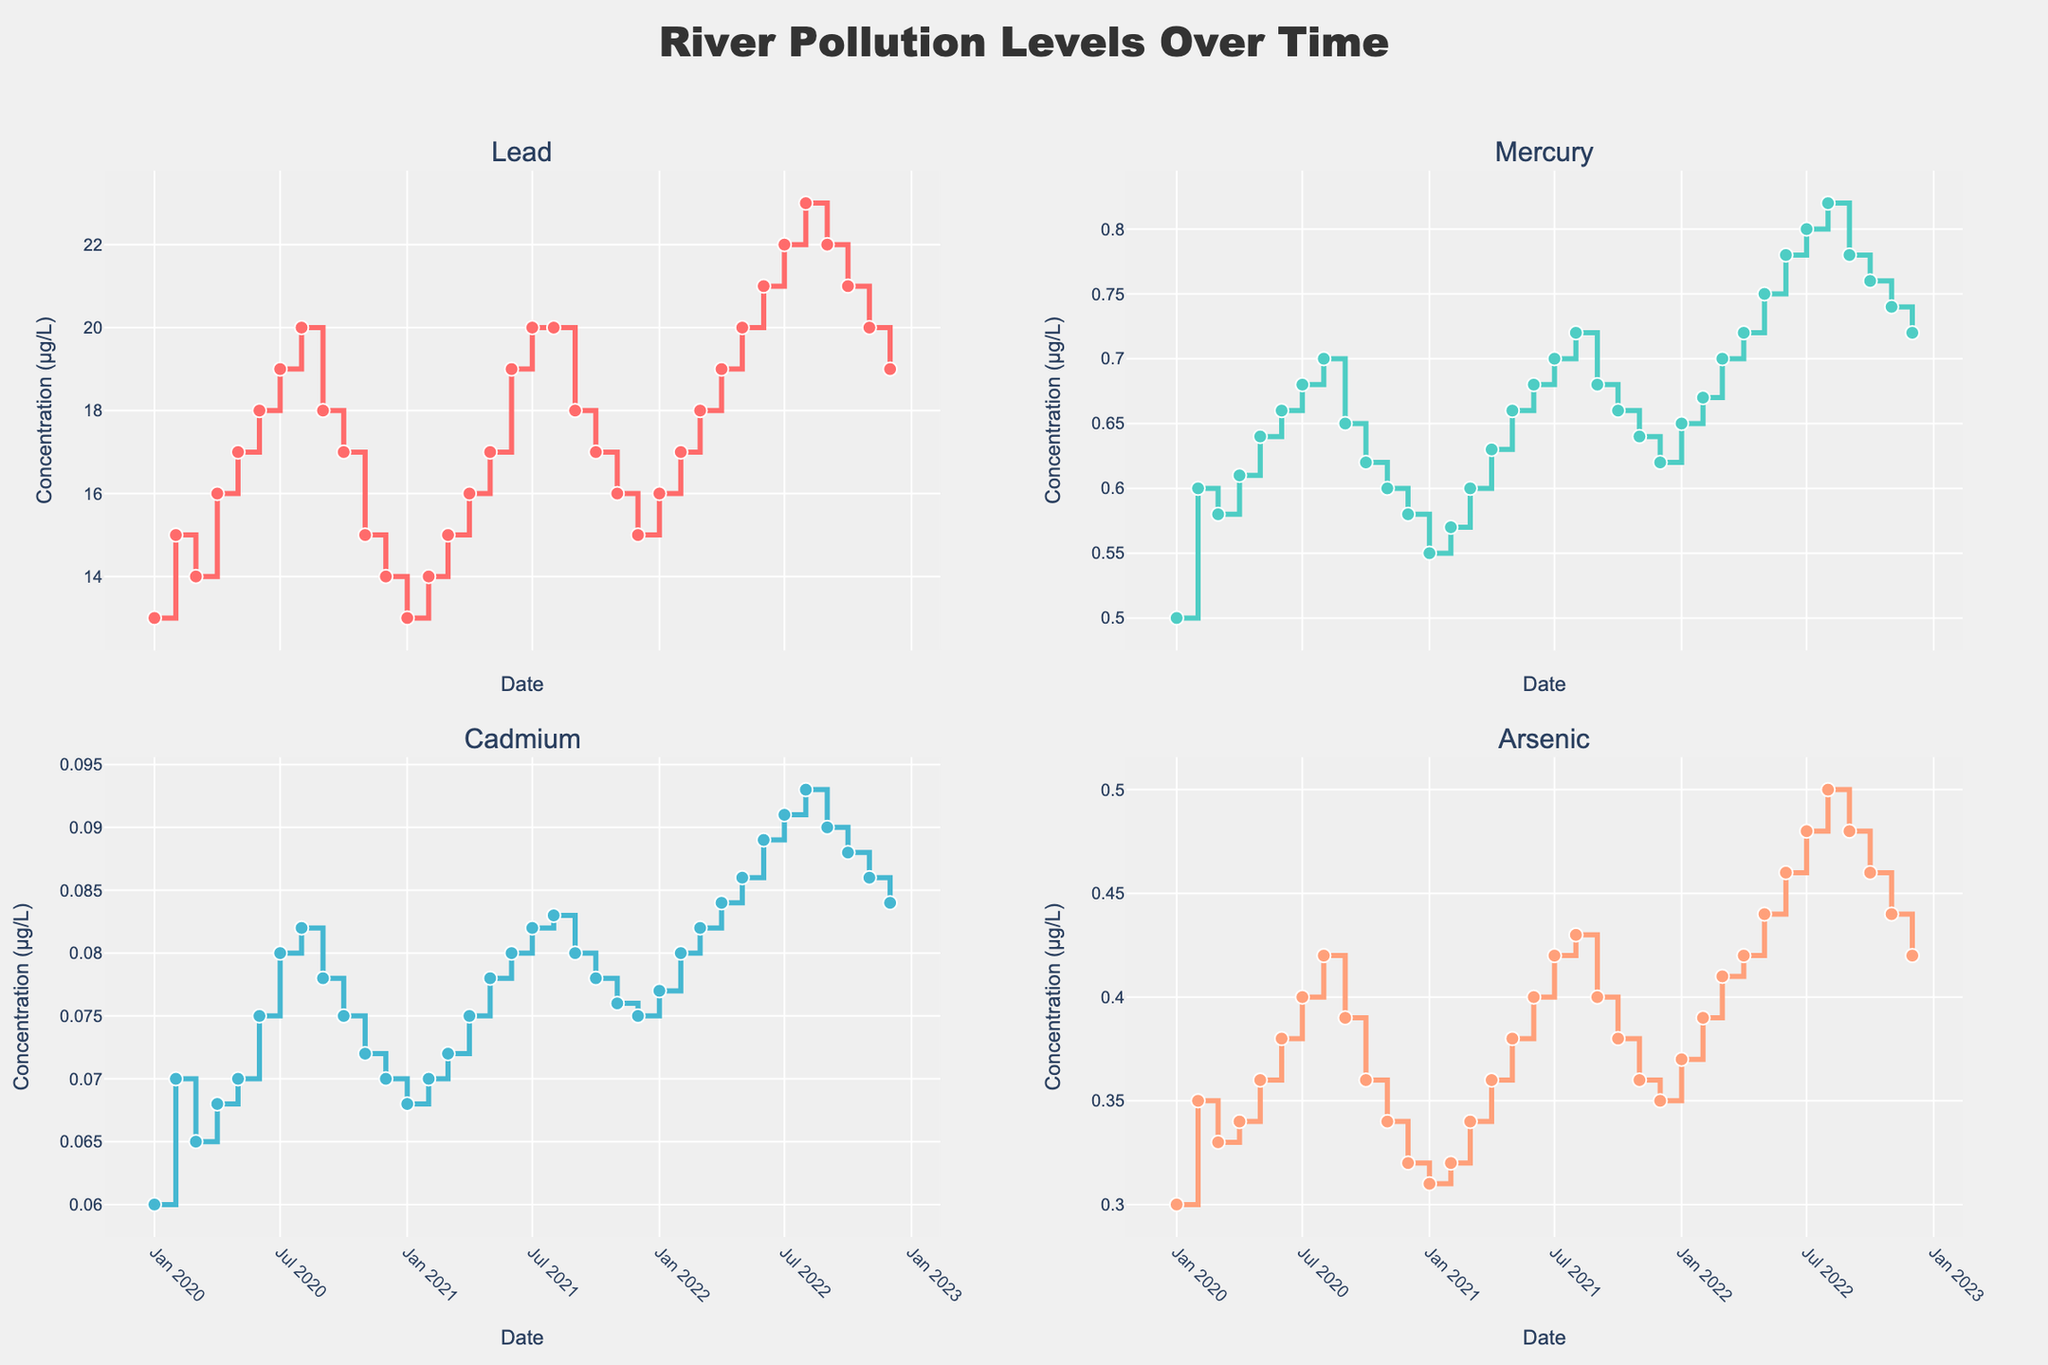What does the title of the figure indicate? The title "River Pollution Levels Over Time" indicates that the figure shows how pollution levels have changed over time in the river.
Answer: It shows pollution levels over time How many pollutants are monitored in the figure? The figure has four subplots, each representing a different pollutant: Lead, Mercury, Cadmium, and Arsenic.
Answer: Four In which month and year was the highest level of Lead observed? The subplot for Lead indicates that the highest level of Lead (23 µg/L) was observed in August 2022.
Answer: August 2022 How did the levels of Mercury change from January 2020 to December 2022? Mercury levels increased from 0.5 µg/L in January 2020 to 0.72 µg/L in December 2022, showing a general upward trend over the three years.
Answer: Increased What is the range of Cadmium concentrations observed in the figure? The lowest Cadmium concentration is 0.06 µg/L (January 2020), and the highest is 0.093 µg/L (August 2022). The range is 0.093 - 0.06 = 0.033 µg/L.
Answer: 0.033 µg/L How does the concentration of Arsenic in July compare across the three years (2020, 2021, 2022)? In July 2020, Arsenic was at 0.4 µg/L; in July 2021, it was 0.42 µg/L; and in July 2022, it was 0.48 µg/L. Therefore, Arsenic levels have steadily increased each July.
Answer: Increased each year What is the most noticeable trend in the Lead levels from 2020 to 2022? The Lead levels generally show an increasing trend from 13 µg/L in January 2020 to 23 µg/L in August 2022, with fluctuations but an overall upward trend.
Answer: Increasing Which pollutant showed the least variation in concentration levels over the observed period? By comparing the variations in the four subplots, Mercury seems to have lesser fluctuations compared to the other pollutants, with a narrower range between its minimum and maximum values.
Answer: Mercury Between which two consecutive months did the Arsenic levels show the steepest increase? The steepest increase in Arsenic levels appears between June 2022 (0.46 µg/L) and July 2022 (0.48 µg/L), showing an increase of 0.02 µg/L.
Answer: June to July 2022 Is there a pollutant that consistently increases in concentration each month without any drop from month to month? None of the pollutants show a consistent increase every month without any drop. All pollutants have at least a few months where their concentration levels decrease.
Answer: No 